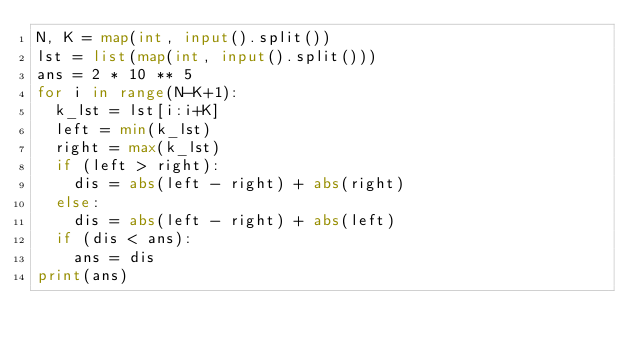Convert code to text. <code><loc_0><loc_0><loc_500><loc_500><_Python_>N, K = map(int, input().split())
lst = list(map(int, input().split()))
ans = 2 * 10 ** 5
for i in range(N-K+1):
	k_lst = lst[i:i+K]
	left = min(k_lst)
	right = max(k_lst)
	if (left > right):
		dis = abs(left - right) + abs(right)
	else:
		dis = abs(left - right) + abs(left)
	if (dis < ans):
		ans = dis    
print(ans)
</code> 